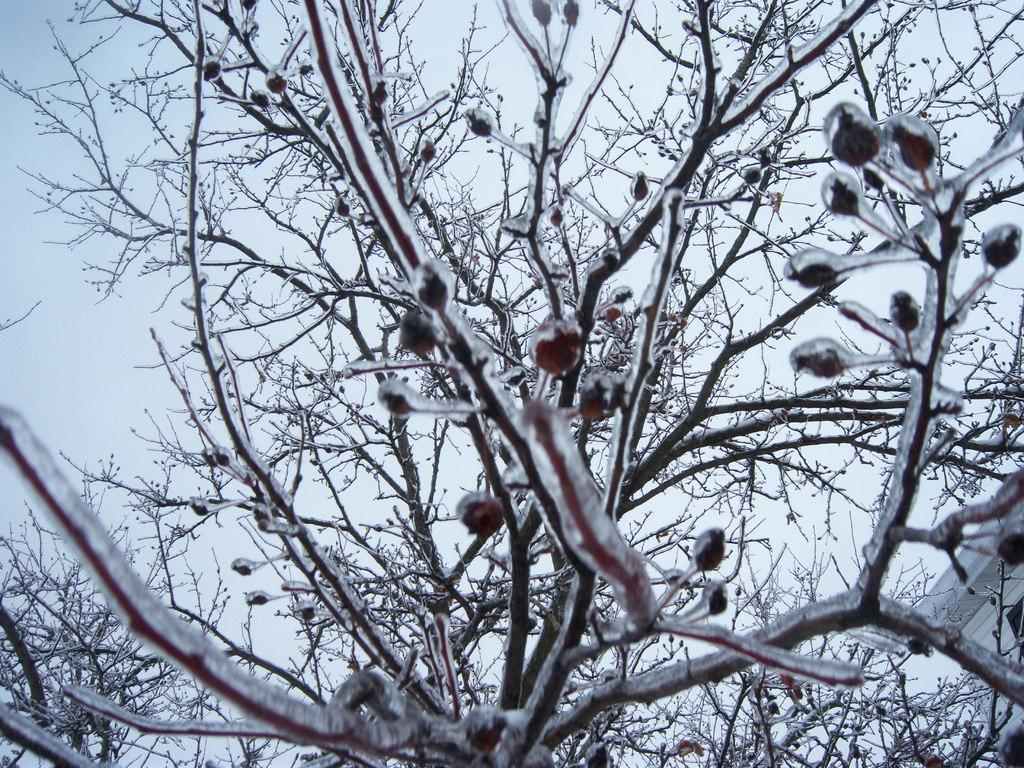What type of natural element is present in the image? There is a tree in the image. What type of man-made structure can be seen in the image? There is a building in the bottom right corner of the image. What part of the natural environment is visible in the image? The sky is visible in the background of the image. What type of vest is being discussed in the image? There is no vest or discussion present in the image. How many trains are visible in the image? There are no trains visible in the image. 